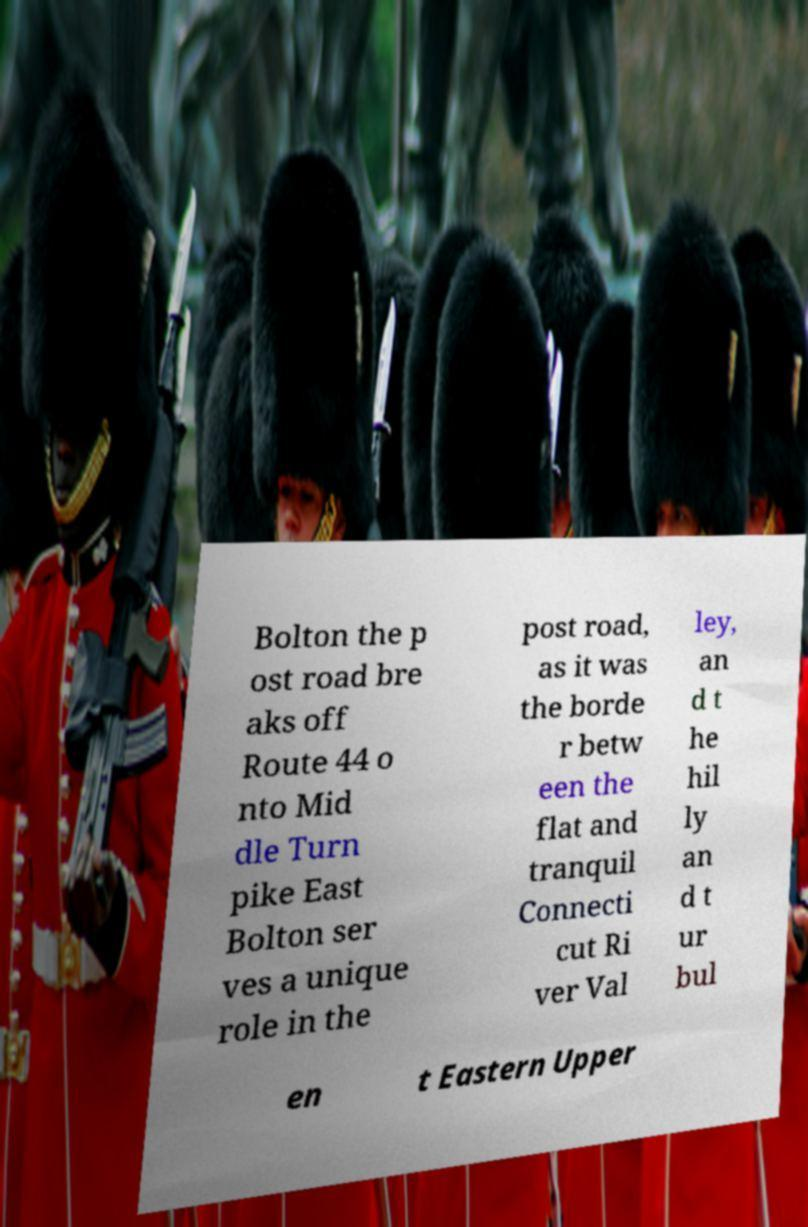Please read and relay the text visible in this image. What does it say? Bolton the p ost road bre aks off Route 44 o nto Mid dle Turn pike East Bolton ser ves a unique role in the post road, as it was the borde r betw een the flat and tranquil Connecti cut Ri ver Val ley, an d t he hil ly an d t ur bul en t Eastern Upper 